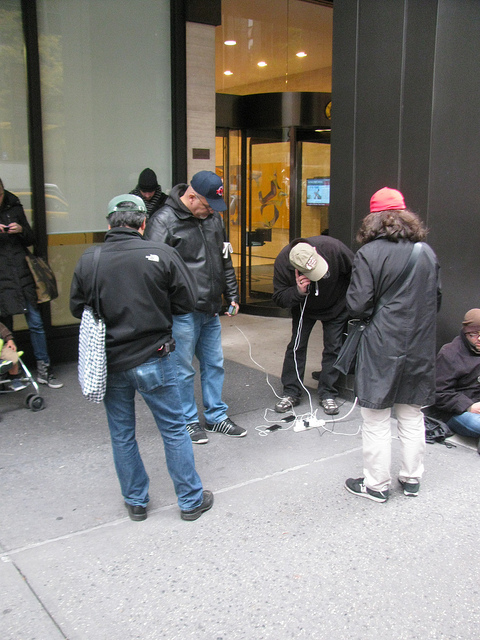Can you tell what time of day it might be in the photo? Given the attire of the individuals, such as thick jackets and hats, and the overall lighting, it seems to be during a cooler part of the day, likely morning or late afternoon. 